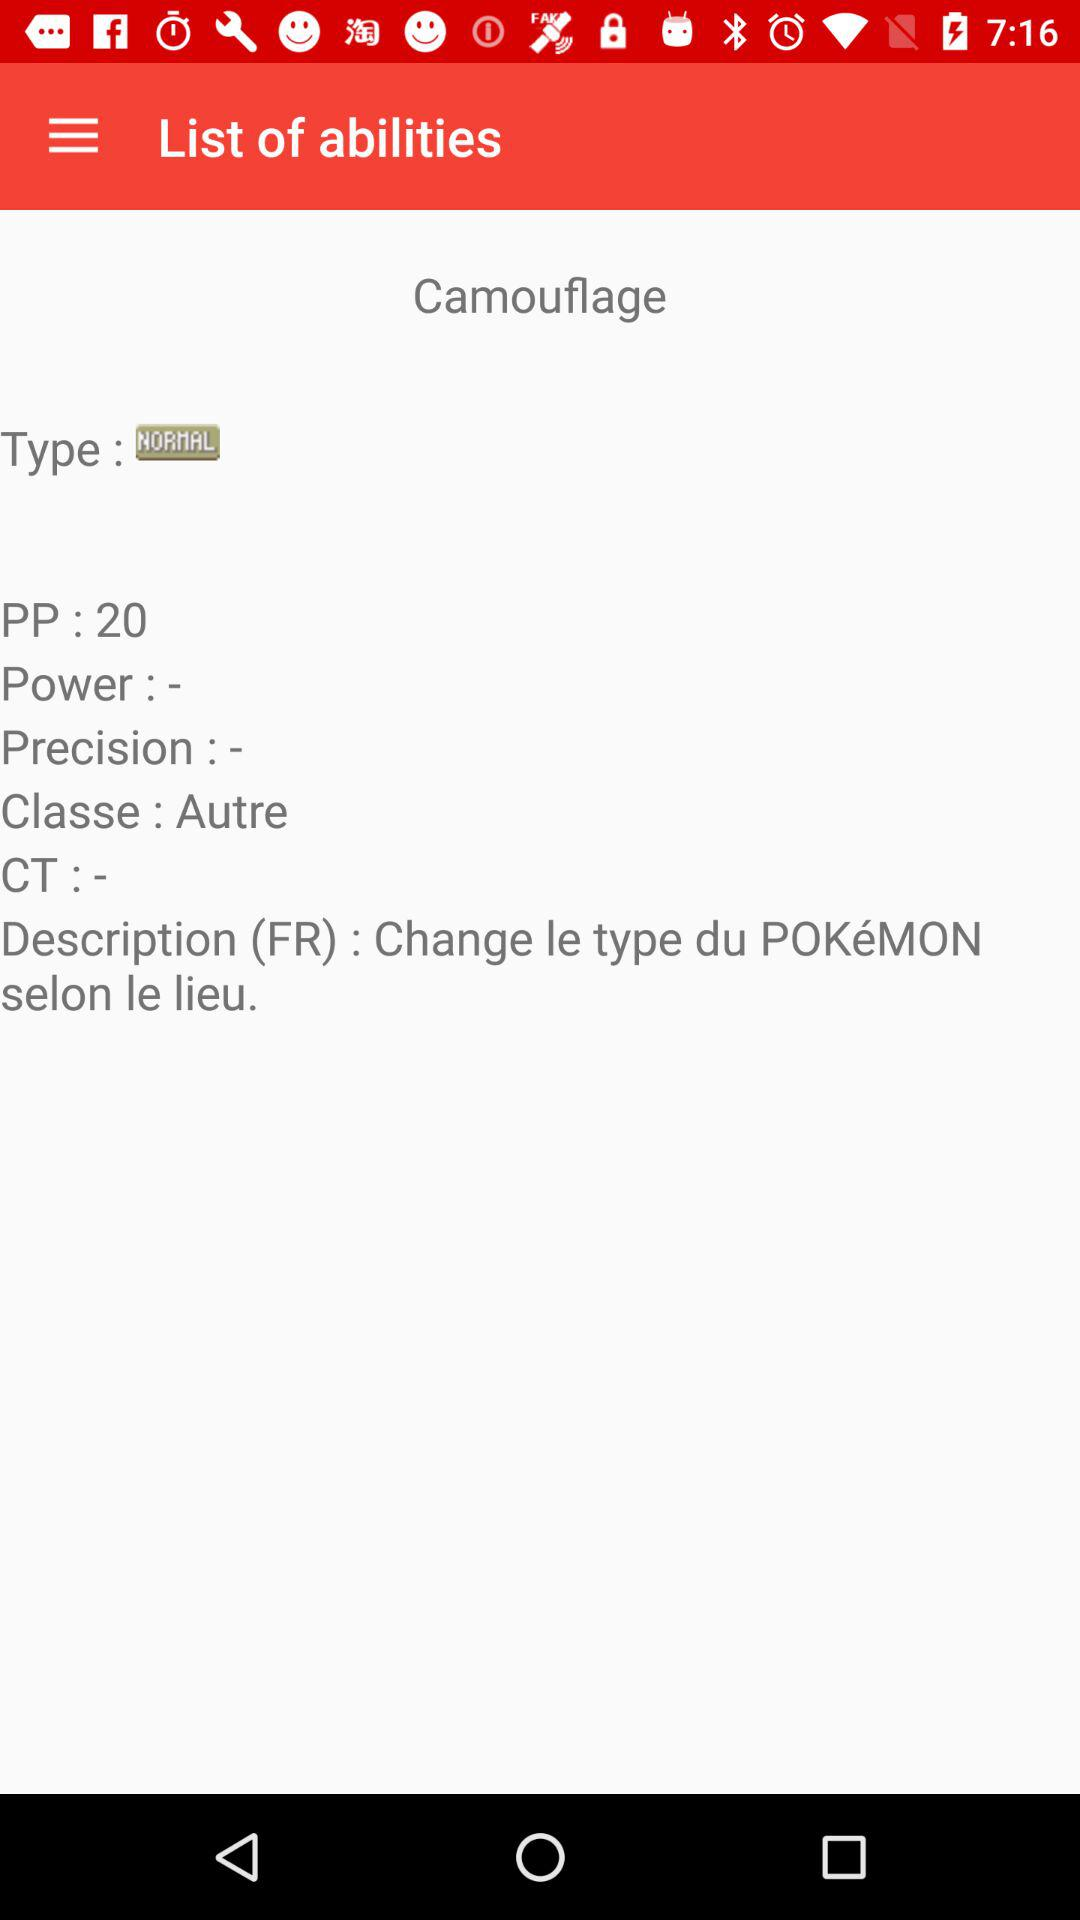What is the PP? The PP is 20. 